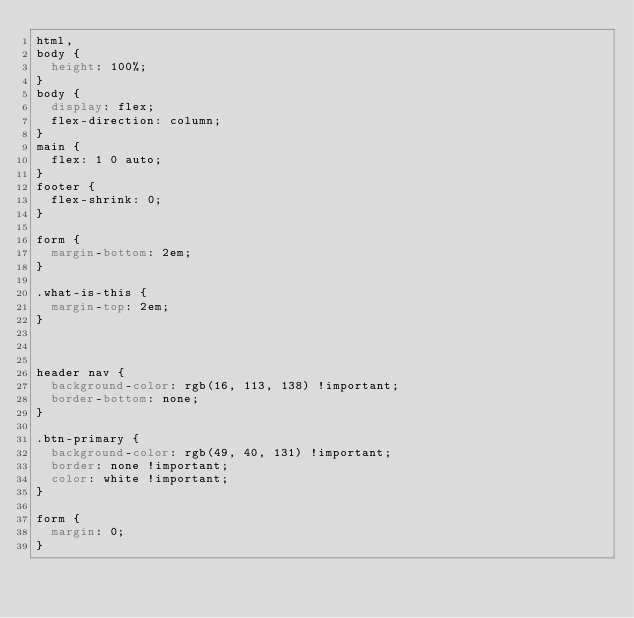<code> <loc_0><loc_0><loc_500><loc_500><_CSS_>html,
body {
  height: 100%;
}
body {
  display: flex;
  flex-direction: column;
}
main {
  flex: 1 0 auto;
}
footer {
  flex-shrink: 0;
}

form {
  margin-bottom: 2em;
}

.what-is-this {
  margin-top: 2em;
}



header nav {
  background-color: rgb(16, 113, 138) !important;
  border-bottom: none;
}

.btn-primary {
  background-color: rgb(49, 40, 131) !important;
  border: none !important;
  color: white !important;
}

form {
  margin: 0;
}</code> 